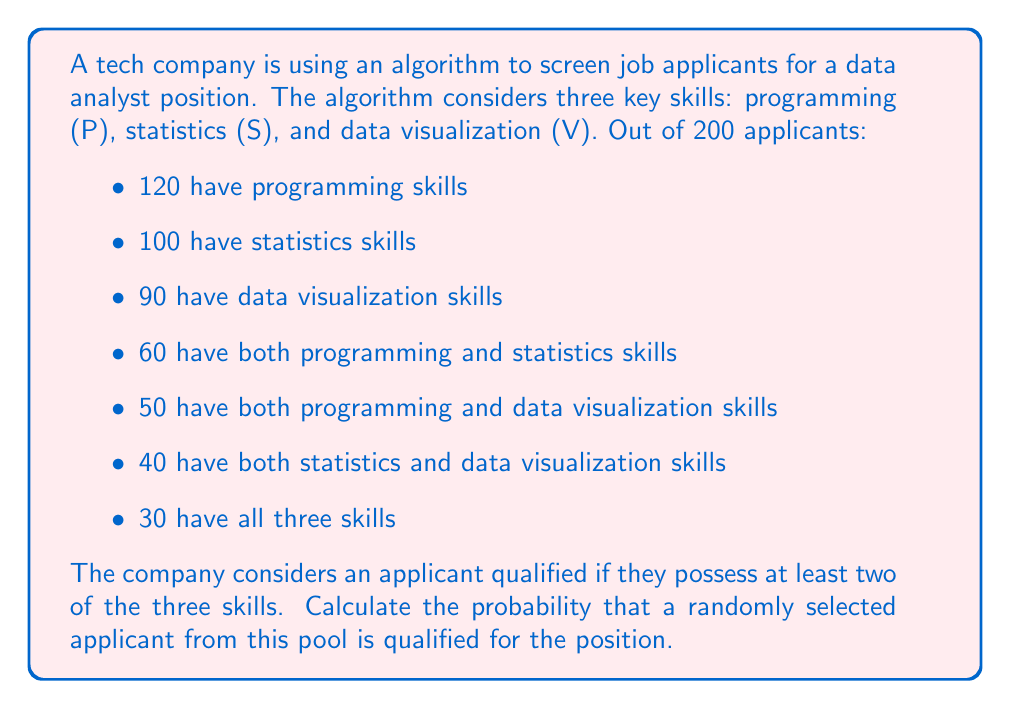What is the answer to this math problem? To solve this problem, we'll use set theory and the inclusion-exclusion principle. Let's break it down step by step:

1) First, let's define our universal set $U$ as all applicants: $|U| = 200$

2) We need to find the number of applicants with at least two skills. This is equivalent to the total number of applicants minus those with one or zero skills.

3) Let's use the inclusion-exclusion principle to find the number of applicants with at least one skill:

   $$|P \cup S \cup V| = |P| + |S| + |V| - |P \cap S| - |P \cap V| - |S \cap V| + |P \cap S \cap V|$$
   $$= 120 + 100 + 90 - 60 - 50 - 40 + 30 = 190$$

4) So, 190 applicants have at least one skill, meaning 10 have no skills.

5) Now, we need to subtract those with exactly one skill:
   - Only P: $120 - 60 - 50 + 30 = 40$
   - Only S: $100 - 60 - 40 + 30 = 30$
   - Only V: $90 - 50 - 40 + 30 = 30$

6) Total with exactly one skill: $40 + 30 + 30 = 100$

7) Therefore, the number of qualified applicants (with at least two skills) is:
   $$200 - 10 - 100 = 90$$

8) The probability is the number of favorable outcomes divided by the total number of possible outcomes:

   $$P(\text{qualified}) = \frac{90}{200} = \frac{9}{20} = 0.45$$
Answer: The probability of selecting a qualified candidate is $\frac{9}{20}$ or $0.45$ or $45\%$. 